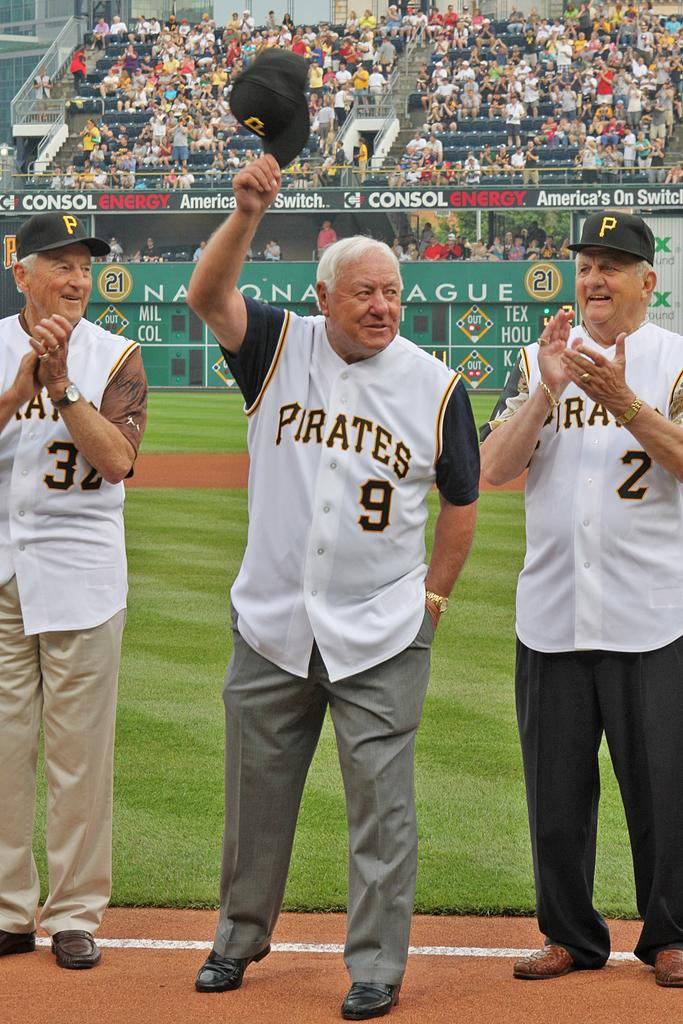Provide a one-sentence caption for the provided image. A group of three older gentleman with Pirates jerseys standing next to each other. 